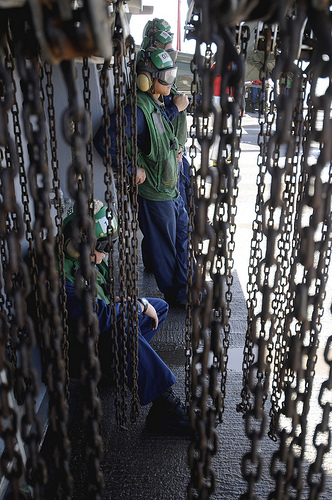<image>
Is there a man behind the chain? Yes. From this viewpoint, the man is positioned behind the chain, with the chain partially or fully occluding the man. 